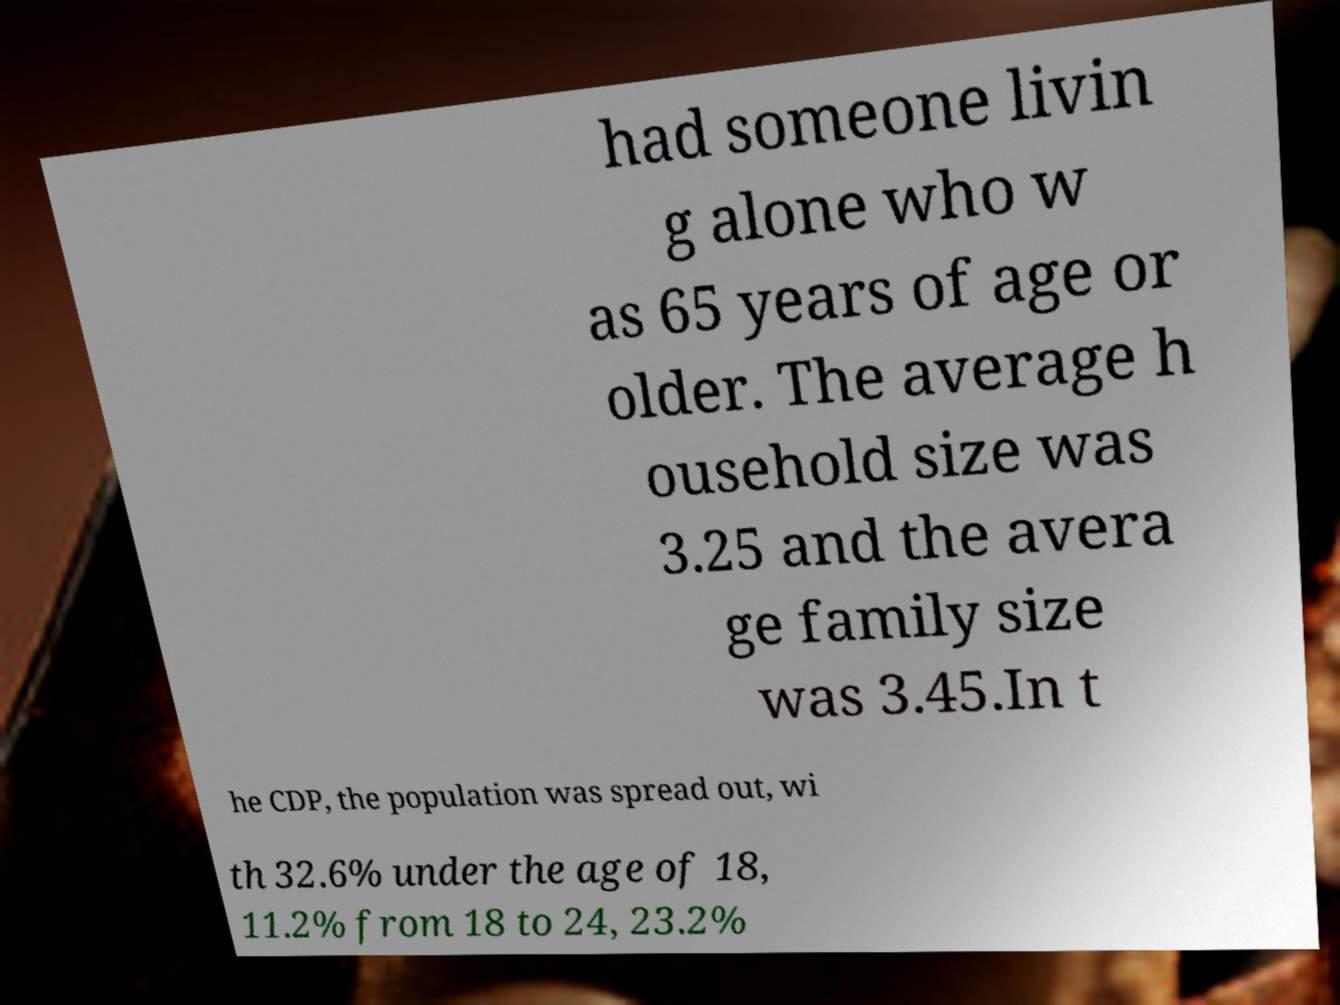Can you read and provide the text displayed in the image?This photo seems to have some interesting text. Can you extract and type it out for me? had someone livin g alone who w as 65 years of age or older. The average h ousehold size was 3.25 and the avera ge family size was 3.45.In t he CDP, the population was spread out, wi th 32.6% under the age of 18, 11.2% from 18 to 24, 23.2% 